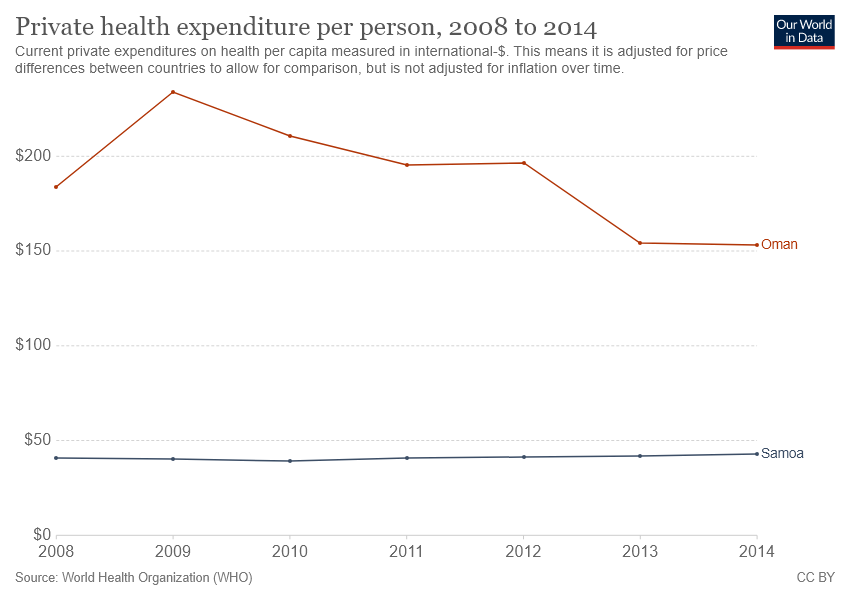Identify some key points in this picture. The private health expenditure per person in Oman experienced the greatest increase in 2009. The brown line represents Oman. 